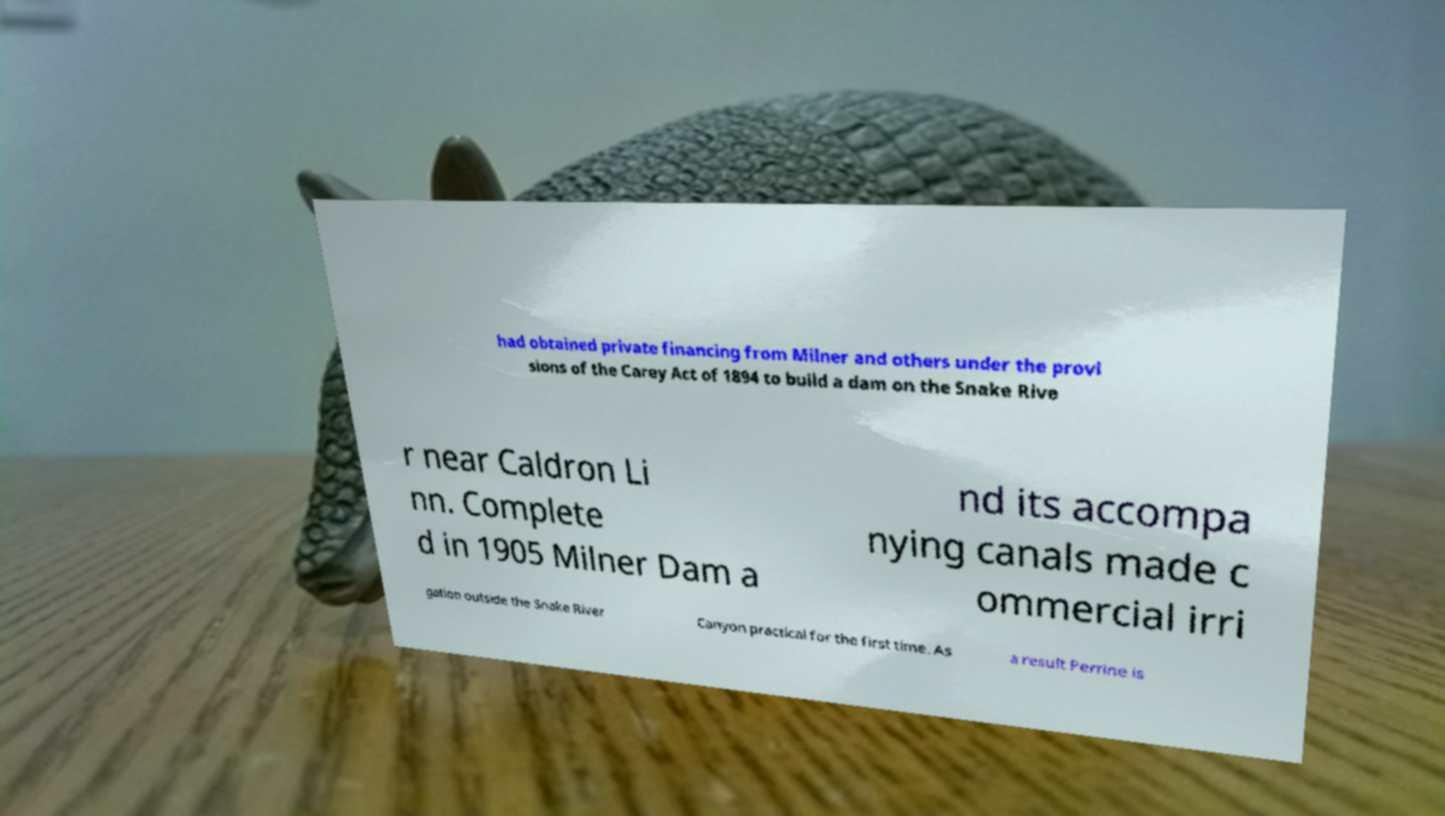I need the written content from this picture converted into text. Can you do that? had obtained private financing from Milner and others under the provi sions of the Carey Act of 1894 to build a dam on the Snake Rive r near Caldron Li nn. Complete d in 1905 Milner Dam a nd its accompa nying canals made c ommercial irri gation outside the Snake River Canyon practical for the first time. As a result Perrine is 